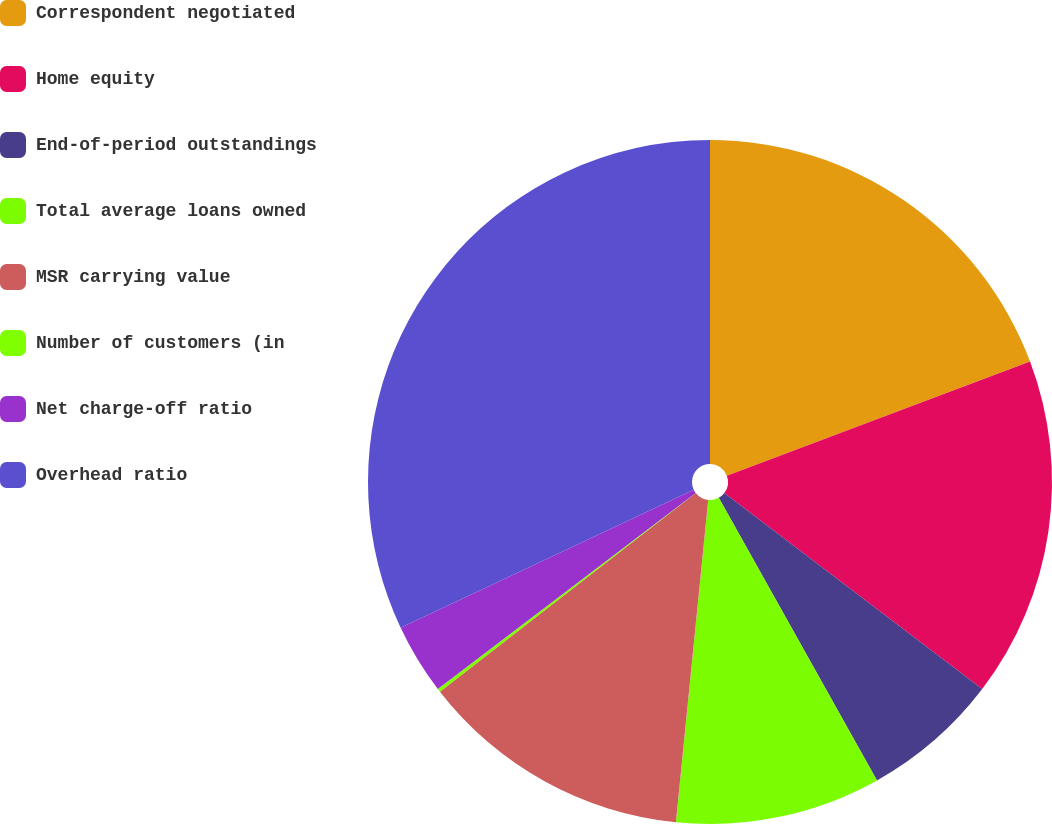<chart> <loc_0><loc_0><loc_500><loc_500><pie_chart><fcel>Correspondent negotiated<fcel>Home equity<fcel>End-of-period outstandings<fcel>Total average loans owned<fcel>MSR carrying value<fcel>Number of customers (in<fcel>Net charge-off ratio<fcel>Overhead ratio<nl><fcel>19.27%<fcel>16.08%<fcel>6.53%<fcel>9.71%<fcel>12.9%<fcel>0.16%<fcel>3.34%<fcel>32.01%<nl></chart> 